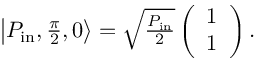<formula> <loc_0><loc_0><loc_500><loc_500>\begin{array} { r } { \left | P _ { i n } , \frac { \pi } { 2 } , 0 \right \rangle = \sqrt { \frac { P _ { i n } } { 2 } } \left ( \begin{array} { c } { 1 } \\ { 1 } \end{array} \right ) . } \end{array}</formula> 